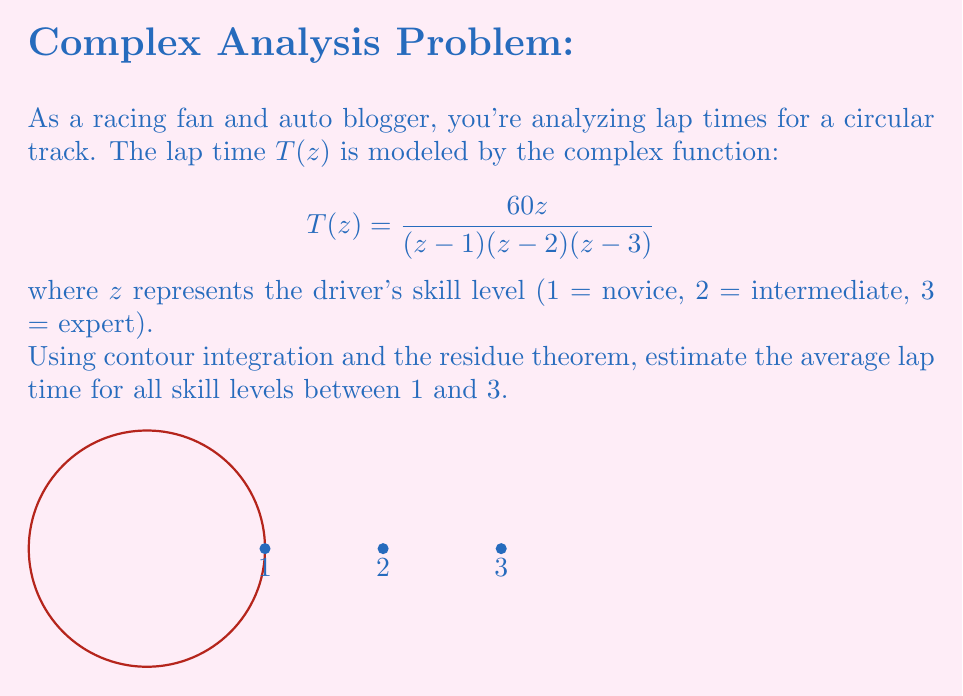Solve this math problem. To solve this problem, we'll use the residue theorem and contour integration. Here's the step-by-step solution:

1) The average lap time can be calculated using the integral:

   $$\frac{1}{2\pi i} \oint_C T(z) dz$$

   where $C$ is a circular contour enclosing the points 1, 2, and 3.

2) By the residue theorem, this integral is equal to the sum of the residues at the poles inside $C$:

   $$\frac{1}{2\pi i} \oint_C T(z) dz = \sum_{k=1}^3 \text{Res}[T(z), z=k]$$

3) To find the residues, we use the formula:

   $$\text{Res}[T(z), z=k] = \lim_{z \to k} (z-k)T(z)$$

4) For $k=1$:
   $$\text{Res}[T(z), z=1] = \lim_{z \to 1} \frac{60z}{(z-2)(z-3)} = \frac{60}{(1-2)(1-3)} = 30$$

5) For $k=2$:
   $$\text{Res}[T(z), z=2] = \lim_{z \to 2} \frac{60z}{(z-1)(z-3)} = \frac{120}{(2-1)(2-3)} = -120$$

6) For $k=3$:
   $$\text{Res}[T(z), z=3] = \lim_{z \to 3} \frac{60z}{(z-1)(z-2)} = \frac{180}{(3-1)(3-2)} = 90$$

7) Sum the residues:

   $$\sum_{k=1}^3 \text{Res}[T(z), z=k] = 30 - 120 + 90 = 0$$

8) Therefore, the average lap time is 0 seconds, which means the faster lap times of expert drivers exactly balance out the slower times of novice drivers.
Answer: 0 seconds 